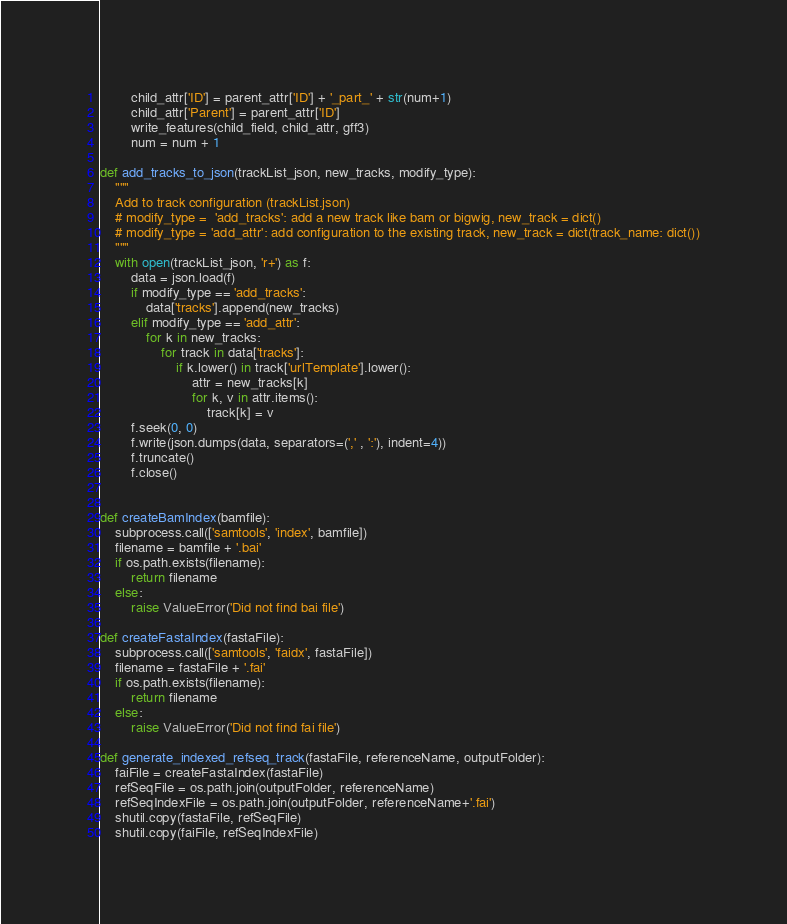<code> <loc_0><loc_0><loc_500><loc_500><_Python_>        child_attr['ID'] = parent_attr['ID'] + '_part_' + str(num+1)
        child_attr['Parent'] = parent_attr['ID']
        write_features(child_field, child_attr, gff3)
        num = num + 1

def add_tracks_to_json(trackList_json, new_tracks, modify_type):
    """
    Add to track configuration (trackList.json)
    # modify_type =  'add_tracks': add a new track like bam or bigwig, new_track = dict()
    # modify_type = 'add_attr': add configuration to the existing track, new_track = dict(track_name: dict())
    """
    with open(trackList_json, 'r+') as f:
        data = json.load(f)
        if modify_type == 'add_tracks':
            data['tracks'].append(new_tracks)
        elif modify_type == 'add_attr':
            for k in new_tracks:
                for track in data['tracks']:
                    if k.lower() in track['urlTemplate'].lower():
                        attr = new_tracks[k]
                        for k, v in attr.items():
                            track[k] = v
        f.seek(0, 0)
        f.write(json.dumps(data, separators=(',' , ':'), indent=4))
        f.truncate()
        f.close()


def createBamIndex(bamfile):
    subprocess.call(['samtools', 'index', bamfile])
    filename = bamfile + '.bai'
    if os.path.exists(filename):
        return filename
    else:
        raise ValueError('Did not find bai file')

def createFastaIndex(fastaFile):
    subprocess.call(['samtools', 'faidx', fastaFile])
    filename = fastaFile + '.fai'
    if os.path.exists(filename):
        return filename
    else:
        raise ValueError('Did not find fai file')

def generate_indexed_refseq_track(fastaFile, referenceName, outputFolder):
    faiFile = createFastaIndex(fastaFile)
    refSeqFile = os.path.join(outputFolder, referenceName)
    refSeqIndexFile = os.path.join(outputFolder, referenceName+'.fai')
    shutil.copy(fastaFile, refSeqFile)
    shutil.copy(faiFile, refSeqIndexFile)
</code> 